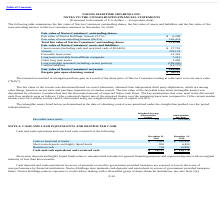According to Navios Maritime Holdings's financial document, What did Short-term deposits and highly liquid funds relate to? amounts held in banks for general financing purposes and represent deposits with an original maturity of less than three months. The document states: "t-term deposits and highly liquid funds relate to amounts held in banks for general financing purposes and represent deposits with an original maturit..." Also, Which years does the table provide information for Cash and cash equivalents and restricted cash? The document shows two values: 2019 and 2018. From the document: "2019 rest in Navios Containers assumed on November 30, 2018:..." Also, What was the amount of restricted cash in 2019? According to the financial document, 736 (in thousands). The relevant text states: "Restricted cash 736 12,892..." Also, can you calculate: What was the change in Short-term deposits and highly liquid funds between 2018 and 2019? Based on the calculation: 950-6,450, the result is -5500 (in thousands). This is based on the information: "Short-term deposits and highly liquid funds 950 6,450 Short-term deposits and highly liquid funds 950 6,450..." The key data points involved are: 6,450, 950. Additionally, Which years did Cash and cash equivalents and restricted cash exceed $100,000? According to the financial document, 2018. The relevant text states: "rest in Navios Containers assumed on November 30, 2018:..." Also, can you calculate: What was the percentage change in the amount of restricted cash between 2018 and 2019? To answer this question, I need to perform calculations using the financial data. The calculation is: (736-12,892)/12,892, which equals -94.29 (percentage). This is based on the information: "Restricted cash 736 12,892 Restricted cash 736 12,892..." The key data points involved are: 12,892, 736. 